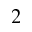Convert formula to latex. <formula><loc_0><loc_0><loc_500><loc_500>^ { 2 }</formula> 